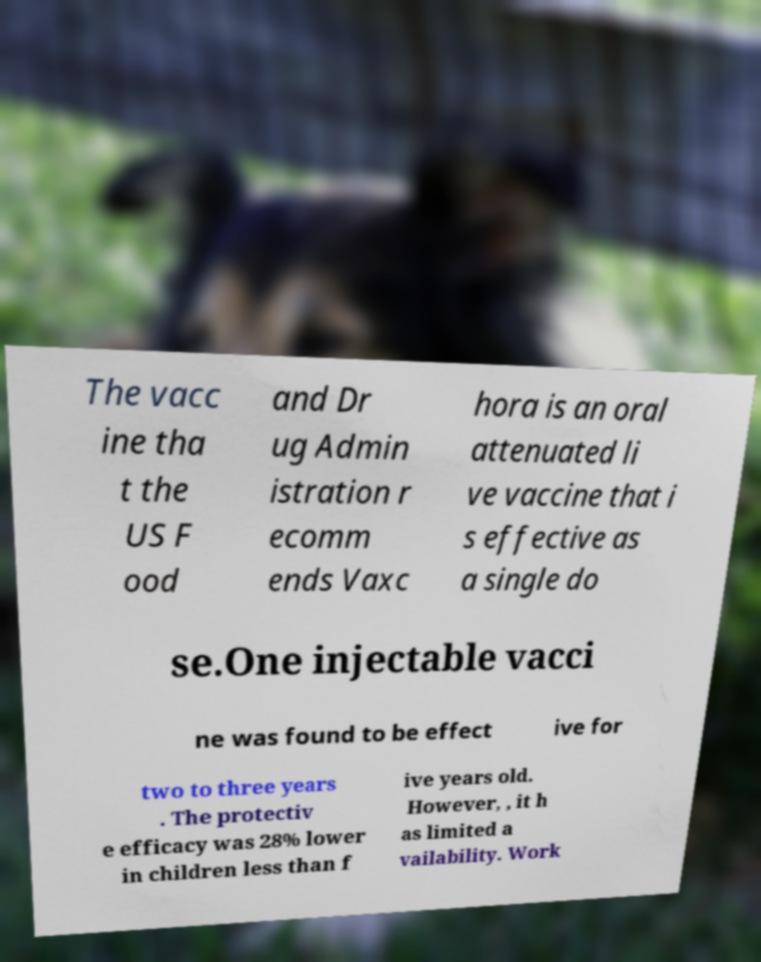What messages or text are displayed in this image? I need them in a readable, typed format. The vacc ine tha t the US F ood and Dr ug Admin istration r ecomm ends Vaxc hora is an oral attenuated li ve vaccine that i s effective as a single do se.One injectable vacci ne was found to be effect ive for two to three years . The protectiv e efficacy was 28% lower in children less than f ive years old. However, , it h as limited a vailability. Work 